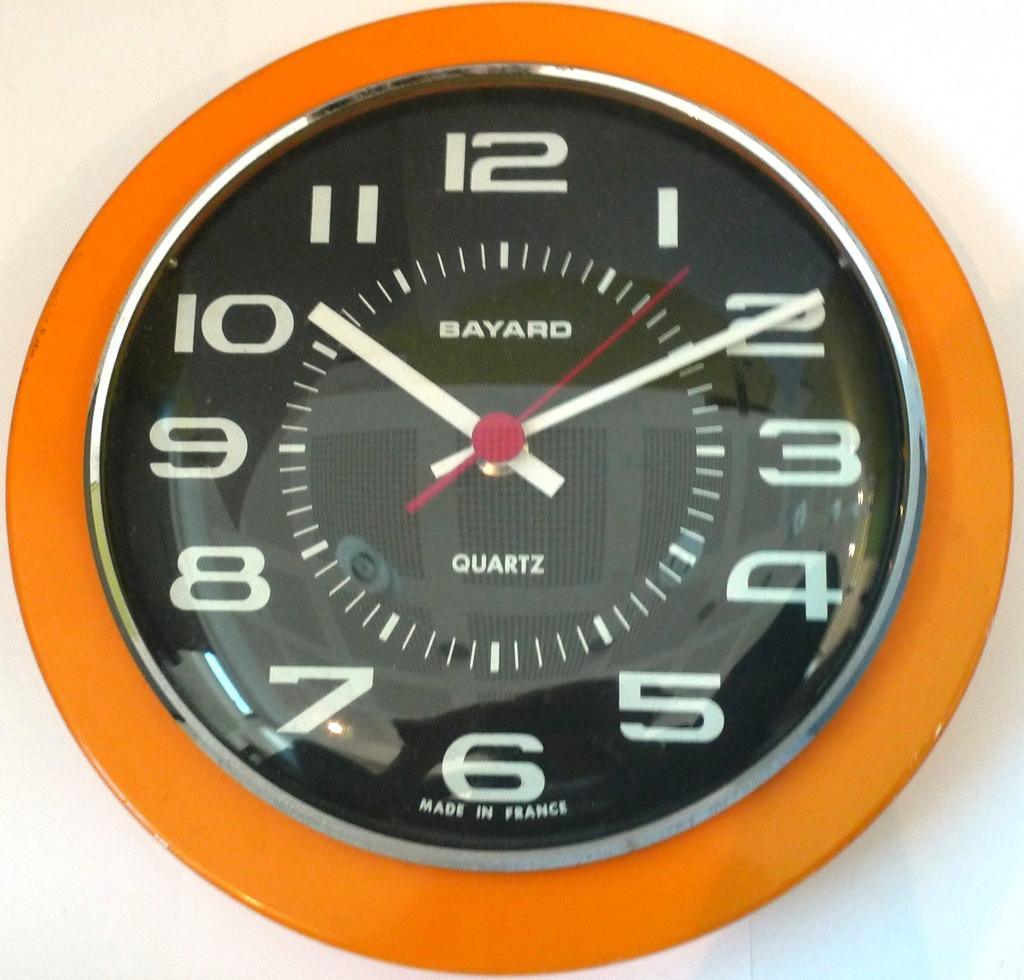<image>
Give a short and clear explanation of the subsequent image. Face of a watch which says "BAYARD" on it. 